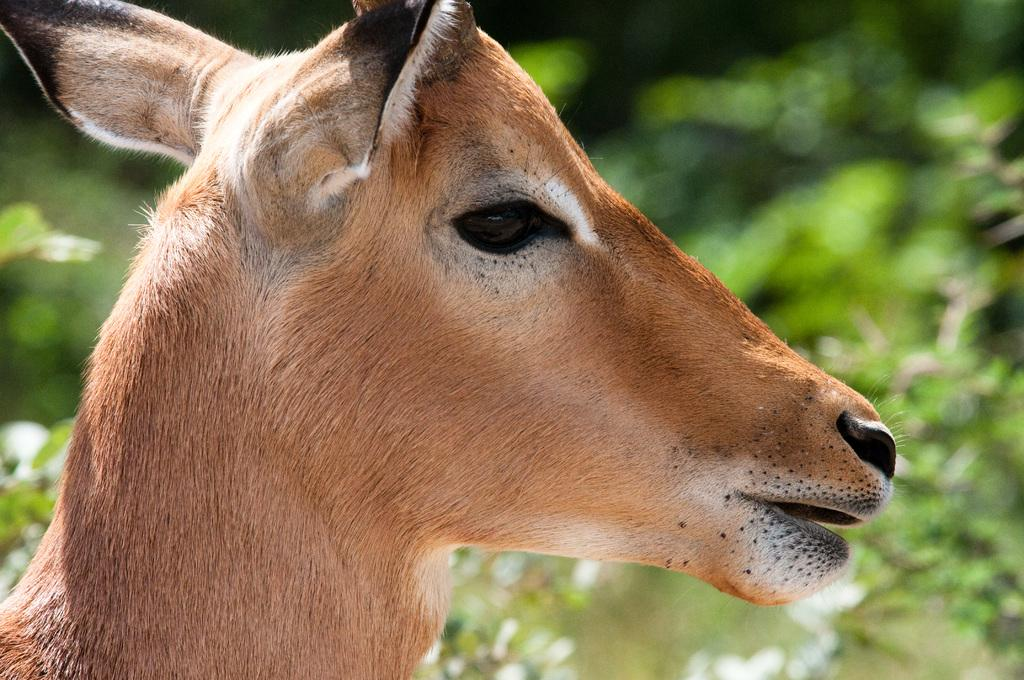What animal's face is depicted in the image? There is a deer face in the image. What type of wax is being used to create the zebra's stripes in the image? There is no zebra or wax present in the image; it features a deer face. 